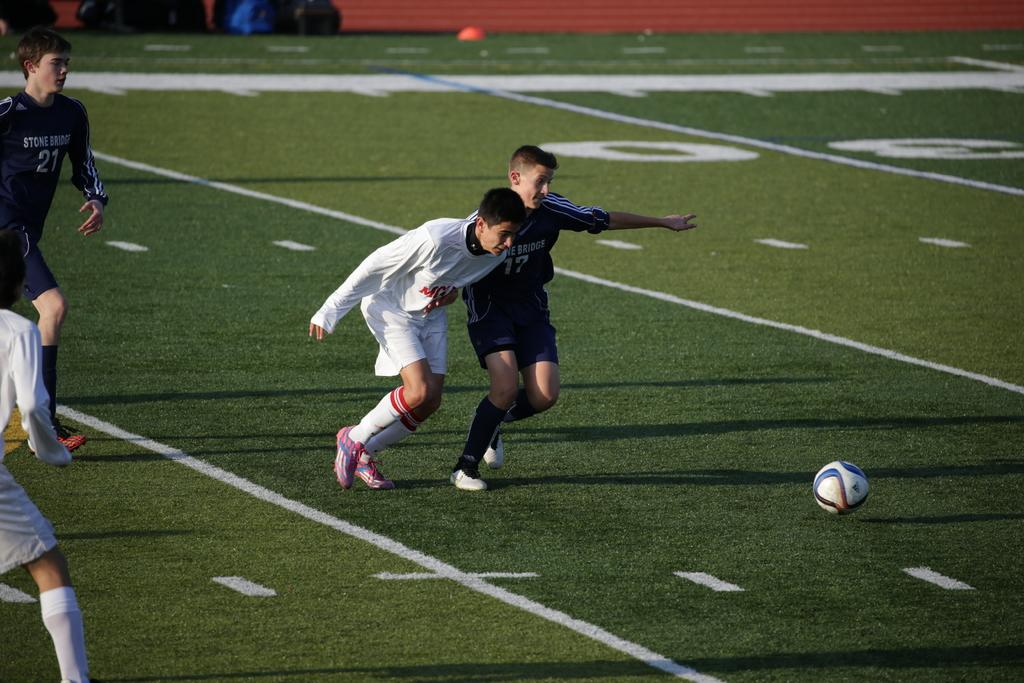<image>
Write a terse but informative summary of the picture. Number 17 of Stone Bridge battles with his opponent for the ball. 